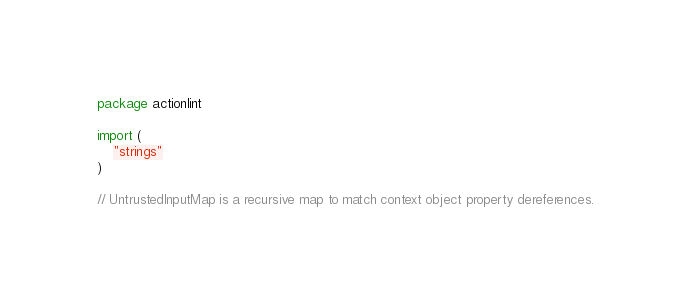<code> <loc_0><loc_0><loc_500><loc_500><_Go_>package actionlint

import (
	"strings"
)

// UntrustedInputMap is a recursive map to match context object property dereferences.</code> 